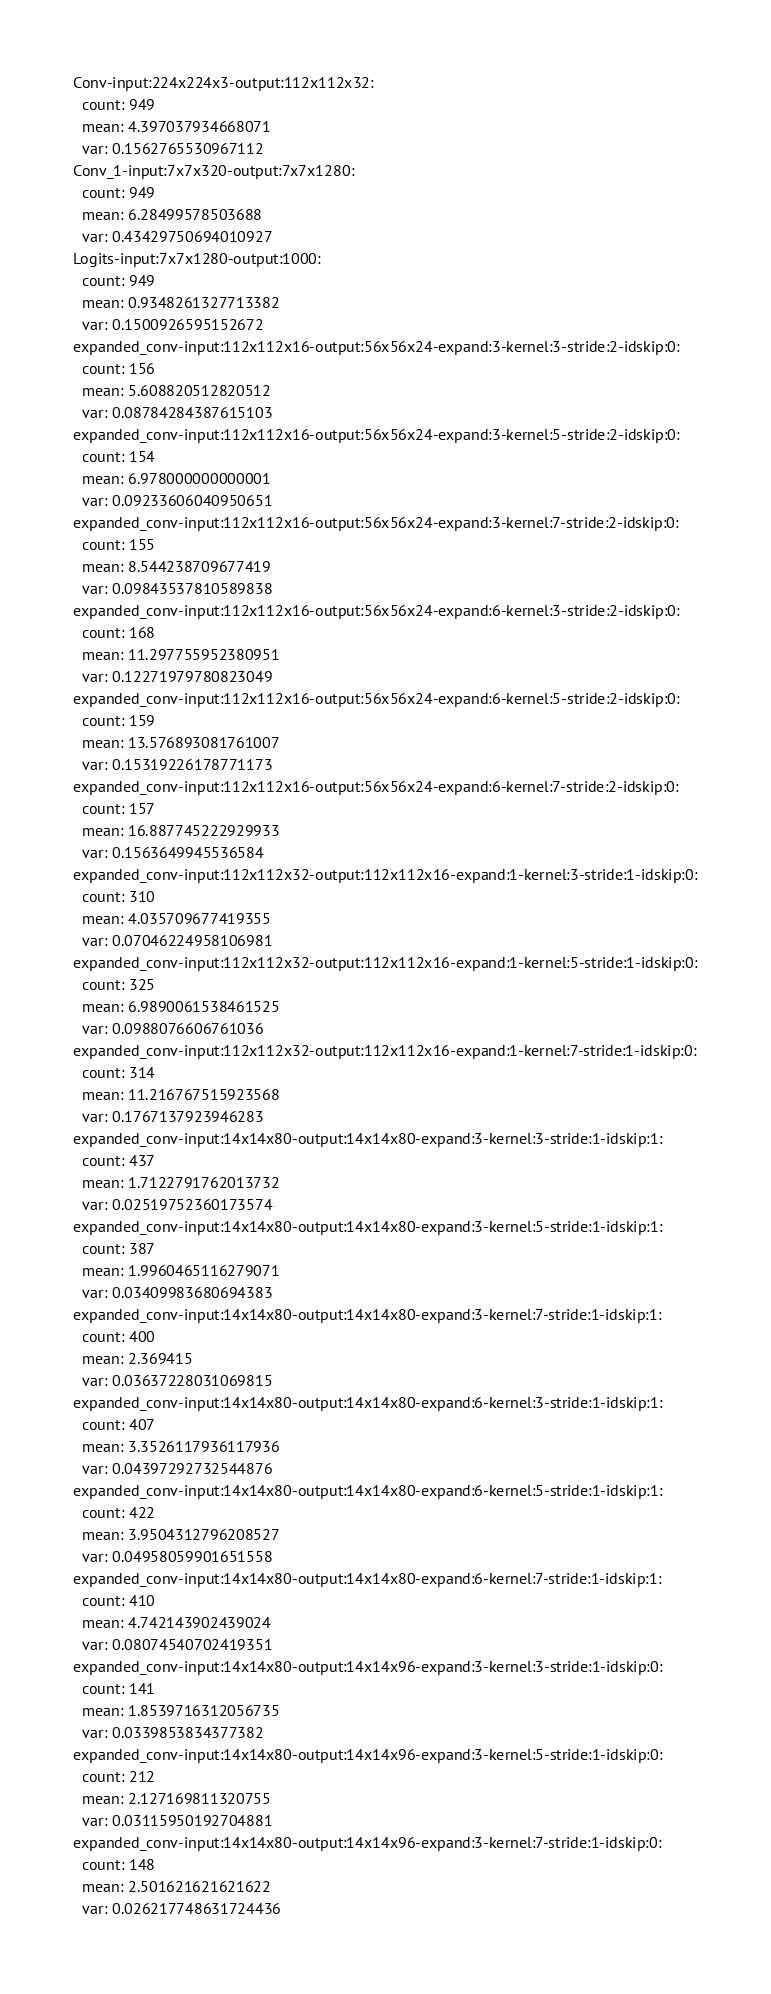Convert code to text. <code><loc_0><loc_0><loc_500><loc_500><_YAML_>Conv-input:224x224x3-output:112x112x32:
  count: 949
  mean: 4.397037934668071
  var: 0.1562765530967112
Conv_1-input:7x7x320-output:7x7x1280:
  count: 949
  mean: 6.28499578503688
  var: 0.43429750694010927
Logits-input:7x7x1280-output:1000:
  count: 949
  mean: 0.9348261327713382
  var: 0.1500926595152672
expanded_conv-input:112x112x16-output:56x56x24-expand:3-kernel:3-stride:2-idskip:0:
  count: 156
  mean: 5.608820512820512
  var: 0.08784284387615103
expanded_conv-input:112x112x16-output:56x56x24-expand:3-kernel:5-stride:2-idskip:0:
  count: 154
  mean: 6.978000000000001
  var: 0.09233606040950651
expanded_conv-input:112x112x16-output:56x56x24-expand:3-kernel:7-stride:2-idskip:0:
  count: 155
  mean: 8.544238709677419
  var: 0.09843537810589838
expanded_conv-input:112x112x16-output:56x56x24-expand:6-kernel:3-stride:2-idskip:0:
  count: 168
  mean: 11.297755952380951
  var: 0.12271979780823049
expanded_conv-input:112x112x16-output:56x56x24-expand:6-kernel:5-stride:2-idskip:0:
  count: 159
  mean: 13.576893081761007
  var: 0.15319226178771173
expanded_conv-input:112x112x16-output:56x56x24-expand:6-kernel:7-stride:2-idskip:0:
  count: 157
  mean: 16.887745222929933
  var: 0.1563649945536584
expanded_conv-input:112x112x32-output:112x112x16-expand:1-kernel:3-stride:1-idskip:0:
  count: 310
  mean: 4.035709677419355
  var: 0.07046224958106981
expanded_conv-input:112x112x32-output:112x112x16-expand:1-kernel:5-stride:1-idskip:0:
  count: 325
  mean: 6.9890061538461525
  var: 0.0988076606761036
expanded_conv-input:112x112x32-output:112x112x16-expand:1-kernel:7-stride:1-idskip:0:
  count: 314
  mean: 11.216767515923568
  var: 0.1767137923946283
expanded_conv-input:14x14x80-output:14x14x80-expand:3-kernel:3-stride:1-idskip:1:
  count: 437
  mean: 1.7122791762013732
  var: 0.02519752360173574
expanded_conv-input:14x14x80-output:14x14x80-expand:3-kernel:5-stride:1-idskip:1:
  count: 387
  mean: 1.9960465116279071
  var: 0.03409983680694383
expanded_conv-input:14x14x80-output:14x14x80-expand:3-kernel:7-stride:1-idskip:1:
  count: 400
  mean: 2.369415
  var: 0.03637228031069815
expanded_conv-input:14x14x80-output:14x14x80-expand:6-kernel:3-stride:1-idskip:1:
  count: 407
  mean: 3.3526117936117936
  var: 0.04397292732544876
expanded_conv-input:14x14x80-output:14x14x80-expand:6-kernel:5-stride:1-idskip:1:
  count: 422
  mean: 3.9504312796208527
  var: 0.04958059901651558
expanded_conv-input:14x14x80-output:14x14x80-expand:6-kernel:7-stride:1-idskip:1:
  count: 410
  mean: 4.742143902439024
  var: 0.08074540702419351
expanded_conv-input:14x14x80-output:14x14x96-expand:3-kernel:3-stride:1-idskip:0:
  count: 141
  mean: 1.8539716312056735
  var: 0.0339853834377382
expanded_conv-input:14x14x80-output:14x14x96-expand:3-kernel:5-stride:1-idskip:0:
  count: 212
  mean: 2.127169811320755
  var: 0.03115950192704881
expanded_conv-input:14x14x80-output:14x14x96-expand:3-kernel:7-stride:1-idskip:0:
  count: 148
  mean: 2.501621621621622
  var: 0.026217748631724436</code> 